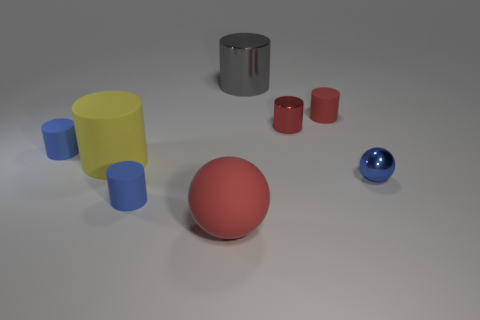Subtract all small shiny cylinders. How many cylinders are left? 5 Subtract 3 cylinders. How many cylinders are left? 3 Subtract all yellow cylinders. How many cylinders are left? 5 Add 2 gray metallic blocks. How many objects exist? 10 Subtract all yellow cylinders. Subtract all purple blocks. How many cylinders are left? 5 Add 5 tiny yellow cylinders. How many tiny yellow cylinders exist? 5 Subtract 0 cyan cylinders. How many objects are left? 8 Subtract all cylinders. How many objects are left? 2 Subtract all red cylinders. Subtract all tiny red objects. How many objects are left? 4 Add 7 shiny cylinders. How many shiny cylinders are left? 9 